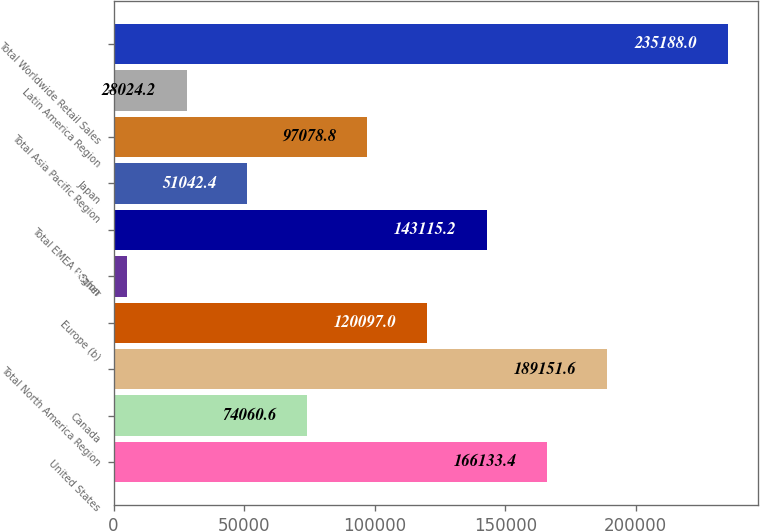<chart> <loc_0><loc_0><loc_500><loc_500><bar_chart><fcel>United States<fcel>Canada<fcel>Total North America Region<fcel>Europe (b)<fcel>Other<fcel>Total EMEA Region<fcel>Japan<fcel>Total Asia Pacific Region<fcel>Latin America Region<fcel>Total Worldwide Retail Sales<nl><fcel>166133<fcel>74060.6<fcel>189152<fcel>120097<fcel>5006<fcel>143115<fcel>51042.4<fcel>97078.8<fcel>28024.2<fcel>235188<nl></chart> 